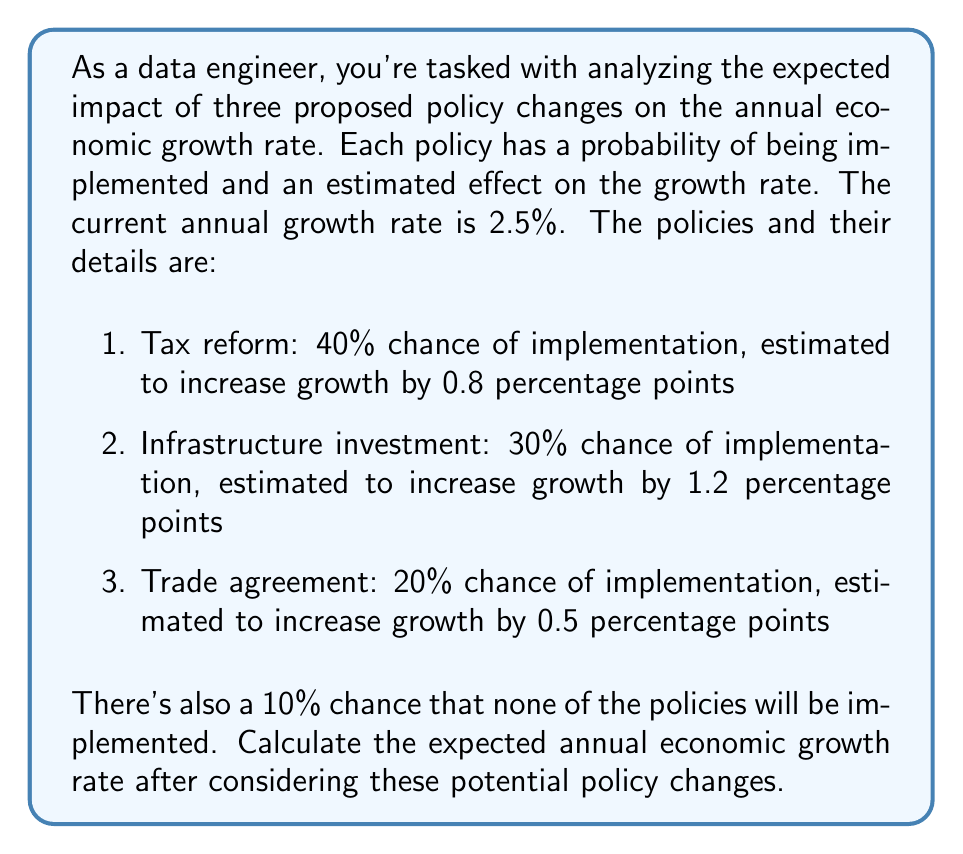Show me your answer to this math problem. To solve this problem, we need to use the concept of expected value. Let's approach this step-by-step:

1. First, let's calculate the new growth rate for each policy if implemented:
   - Tax reform: $2.5\% + 0.8\% = 3.3\%$
   - Infrastructure investment: $2.5\% + 1.2\% = 3.7\%$
   - Trade agreement: $2.5\% + 0.5\% = 3.0\%$

2. Now, let's calculate the expected value of the growth rate for each scenario:
   - Tax reform: $0.40 \times 3.3\% = 1.32\%$
   - Infrastructure investment: $0.30 \times 3.7\% = 1.11\%$
   - Trade agreement: $0.20 \times 3.0\% = 0.60\%$
   - No change: $0.10 \times 2.5\% = 0.25\%$

3. The expected growth rate is the sum of these values:

   $$E(\text{growth rate}) = 1.32\% + 1.11\% + 0.60\% + 0.25\% = 3.28\%$$

Therefore, the expected annual economic growth rate after considering these potential policy changes is 3.28%.
Answer: 3.28% 